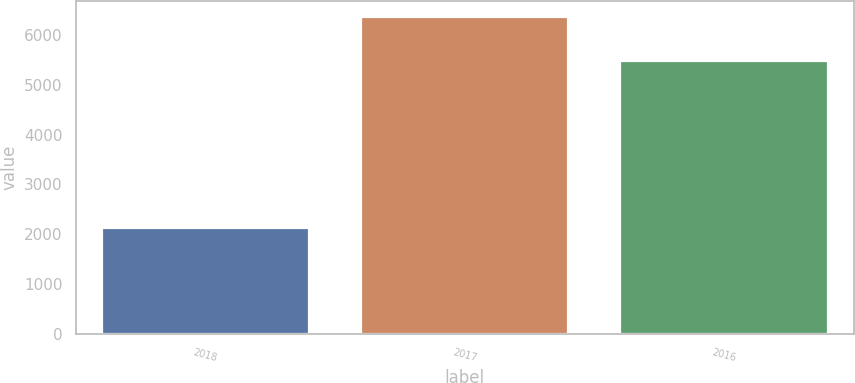Convert chart to OTSL. <chart><loc_0><loc_0><loc_500><loc_500><bar_chart><fcel>2018<fcel>2017<fcel>2016<nl><fcel>2128<fcel>6363<fcel>5473<nl></chart> 